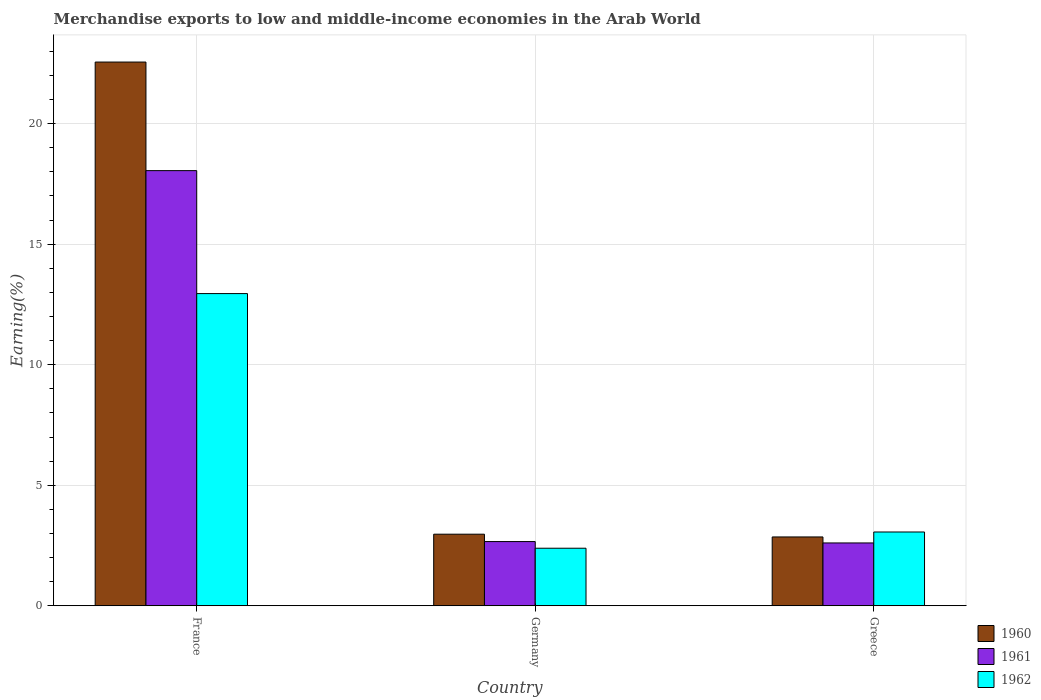How many different coloured bars are there?
Provide a succinct answer. 3. How many bars are there on the 3rd tick from the left?
Your answer should be compact. 3. How many bars are there on the 2nd tick from the right?
Offer a terse response. 3. In how many cases, is the number of bars for a given country not equal to the number of legend labels?
Your response must be concise. 0. What is the percentage of amount earned from merchandise exports in 1962 in Germany?
Offer a very short reply. 2.39. Across all countries, what is the maximum percentage of amount earned from merchandise exports in 1961?
Make the answer very short. 18.05. Across all countries, what is the minimum percentage of amount earned from merchandise exports in 1962?
Keep it short and to the point. 2.39. In which country was the percentage of amount earned from merchandise exports in 1962 maximum?
Provide a succinct answer. France. What is the total percentage of amount earned from merchandise exports in 1960 in the graph?
Your answer should be compact. 28.38. What is the difference between the percentage of amount earned from merchandise exports in 1960 in France and that in Greece?
Your answer should be compact. 19.7. What is the difference between the percentage of amount earned from merchandise exports in 1960 in Greece and the percentage of amount earned from merchandise exports in 1962 in Germany?
Make the answer very short. 0.47. What is the average percentage of amount earned from merchandise exports in 1961 per country?
Provide a short and direct response. 7.77. What is the difference between the percentage of amount earned from merchandise exports of/in 1961 and percentage of amount earned from merchandise exports of/in 1962 in Greece?
Make the answer very short. -0.45. In how many countries, is the percentage of amount earned from merchandise exports in 1961 greater than 5 %?
Your answer should be very brief. 1. What is the ratio of the percentage of amount earned from merchandise exports in 1962 in Germany to that in Greece?
Ensure brevity in your answer.  0.78. Is the percentage of amount earned from merchandise exports in 1961 in Germany less than that in Greece?
Offer a terse response. No. Is the difference between the percentage of amount earned from merchandise exports in 1961 in France and Greece greater than the difference between the percentage of amount earned from merchandise exports in 1962 in France and Greece?
Your answer should be very brief. Yes. What is the difference between the highest and the second highest percentage of amount earned from merchandise exports in 1962?
Your response must be concise. -0.67. What is the difference between the highest and the lowest percentage of amount earned from merchandise exports in 1960?
Your answer should be compact. 19.7. In how many countries, is the percentage of amount earned from merchandise exports in 1961 greater than the average percentage of amount earned from merchandise exports in 1961 taken over all countries?
Keep it short and to the point. 1. Is the sum of the percentage of amount earned from merchandise exports in 1960 in France and Germany greater than the maximum percentage of amount earned from merchandise exports in 1962 across all countries?
Provide a succinct answer. Yes. What does the 3rd bar from the right in France represents?
Offer a terse response. 1960. How many bars are there?
Provide a succinct answer. 9. Are all the bars in the graph horizontal?
Offer a very short reply. No. How many countries are there in the graph?
Provide a succinct answer. 3. Are the values on the major ticks of Y-axis written in scientific E-notation?
Your answer should be compact. No. Does the graph contain any zero values?
Provide a succinct answer. No. Does the graph contain grids?
Make the answer very short. Yes. Where does the legend appear in the graph?
Offer a terse response. Bottom right. How many legend labels are there?
Make the answer very short. 3. What is the title of the graph?
Provide a short and direct response. Merchandise exports to low and middle-income economies in the Arab World. Does "1998" appear as one of the legend labels in the graph?
Offer a very short reply. No. What is the label or title of the X-axis?
Provide a succinct answer. Country. What is the label or title of the Y-axis?
Offer a terse response. Earning(%). What is the Earning(%) in 1960 in France?
Provide a short and direct response. 22.55. What is the Earning(%) in 1961 in France?
Provide a short and direct response. 18.05. What is the Earning(%) of 1962 in France?
Your answer should be compact. 12.95. What is the Earning(%) in 1960 in Germany?
Provide a short and direct response. 2.97. What is the Earning(%) of 1961 in Germany?
Offer a very short reply. 2.66. What is the Earning(%) in 1962 in Germany?
Make the answer very short. 2.39. What is the Earning(%) of 1960 in Greece?
Your answer should be compact. 2.86. What is the Earning(%) of 1961 in Greece?
Offer a very short reply. 2.61. What is the Earning(%) in 1962 in Greece?
Ensure brevity in your answer.  3.06. Across all countries, what is the maximum Earning(%) of 1960?
Offer a very short reply. 22.55. Across all countries, what is the maximum Earning(%) of 1961?
Your answer should be compact. 18.05. Across all countries, what is the maximum Earning(%) of 1962?
Give a very brief answer. 12.95. Across all countries, what is the minimum Earning(%) of 1960?
Your answer should be compact. 2.86. Across all countries, what is the minimum Earning(%) in 1961?
Provide a succinct answer. 2.61. Across all countries, what is the minimum Earning(%) of 1962?
Your response must be concise. 2.39. What is the total Earning(%) of 1960 in the graph?
Offer a terse response. 28.38. What is the total Earning(%) in 1961 in the graph?
Offer a very short reply. 23.32. What is the total Earning(%) in 1962 in the graph?
Keep it short and to the point. 18.4. What is the difference between the Earning(%) in 1960 in France and that in Germany?
Ensure brevity in your answer.  19.58. What is the difference between the Earning(%) in 1961 in France and that in Germany?
Your answer should be compact. 15.38. What is the difference between the Earning(%) of 1962 in France and that in Germany?
Provide a short and direct response. 10.56. What is the difference between the Earning(%) of 1960 in France and that in Greece?
Ensure brevity in your answer.  19.7. What is the difference between the Earning(%) in 1961 in France and that in Greece?
Provide a succinct answer. 15.44. What is the difference between the Earning(%) of 1962 in France and that in Greece?
Ensure brevity in your answer.  9.89. What is the difference between the Earning(%) in 1960 in Germany and that in Greece?
Offer a terse response. 0.11. What is the difference between the Earning(%) of 1961 in Germany and that in Greece?
Ensure brevity in your answer.  0.06. What is the difference between the Earning(%) in 1962 in Germany and that in Greece?
Your answer should be compact. -0.67. What is the difference between the Earning(%) in 1960 in France and the Earning(%) in 1961 in Germany?
Provide a short and direct response. 19.89. What is the difference between the Earning(%) of 1960 in France and the Earning(%) of 1962 in Germany?
Provide a short and direct response. 20.16. What is the difference between the Earning(%) of 1961 in France and the Earning(%) of 1962 in Germany?
Your answer should be very brief. 15.66. What is the difference between the Earning(%) in 1960 in France and the Earning(%) in 1961 in Greece?
Ensure brevity in your answer.  19.95. What is the difference between the Earning(%) of 1960 in France and the Earning(%) of 1962 in Greece?
Give a very brief answer. 19.49. What is the difference between the Earning(%) of 1961 in France and the Earning(%) of 1962 in Greece?
Offer a very short reply. 14.99. What is the difference between the Earning(%) of 1960 in Germany and the Earning(%) of 1961 in Greece?
Offer a very short reply. 0.36. What is the difference between the Earning(%) of 1960 in Germany and the Earning(%) of 1962 in Greece?
Offer a very short reply. -0.09. What is the difference between the Earning(%) of 1961 in Germany and the Earning(%) of 1962 in Greece?
Your response must be concise. -0.4. What is the average Earning(%) in 1960 per country?
Provide a short and direct response. 9.46. What is the average Earning(%) in 1961 per country?
Provide a short and direct response. 7.77. What is the average Earning(%) of 1962 per country?
Provide a succinct answer. 6.13. What is the difference between the Earning(%) in 1960 and Earning(%) in 1961 in France?
Offer a very short reply. 4.5. What is the difference between the Earning(%) of 1960 and Earning(%) of 1962 in France?
Provide a succinct answer. 9.6. What is the difference between the Earning(%) in 1961 and Earning(%) in 1962 in France?
Offer a very short reply. 5.1. What is the difference between the Earning(%) of 1960 and Earning(%) of 1961 in Germany?
Provide a succinct answer. 0.31. What is the difference between the Earning(%) in 1960 and Earning(%) in 1962 in Germany?
Your answer should be compact. 0.58. What is the difference between the Earning(%) in 1961 and Earning(%) in 1962 in Germany?
Make the answer very short. 0.28. What is the difference between the Earning(%) of 1960 and Earning(%) of 1961 in Greece?
Keep it short and to the point. 0.25. What is the difference between the Earning(%) of 1960 and Earning(%) of 1962 in Greece?
Offer a very short reply. -0.21. What is the difference between the Earning(%) in 1961 and Earning(%) in 1962 in Greece?
Your response must be concise. -0.45. What is the ratio of the Earning(%) of 1960 in France to that in Germany?
Provide a short and direct response. 7.59. What is the ratio of the Earning(%) of 1961 in France to that in Germany?
Provide a succinct answer. 6.78. What is the ratio of the Earning(%) of 1962 in France to that in Germany?
Make the answer very short. 5.42. What is the ratio of the Earning(%) in 1960 in France to that in Greece?
Your answer should be very brief. 7.9. What is the ratio of the Earning(%) of 1961 in France to that in Greece?
Provide a short and direct response. 6.92. What is the ratio of the Earning(%) in 1962 in France to that in Greece?
Your answer should be very brief. 4.23. What is the ratio of the Earning(%) of 1961 in Germany to that in Greece?
Your answer should be very brief. 1.02. What is the ratio of the Earning(%) of 1962 in Germany to that in Greece?
Provide a short and direct response. 0.78. What is the difference between the highest and the second highest Earning(%) of 1960?
Give a very brief answer. 19.58. What is the difference between the highest and the second highest Earning(%) of 1961?
Keep it short and to the point. 15.38. What is the difference between the highest and the second highest Earning(%) of 1962?
Provide a short and direct response. 9.89. What is the difference between the highest and the lowest Earning(%) of 1960?
Ensure brevity in your answer.  19.7. What is the difference between the highest and the lowest Earning(%) of 1961?
Offer a very short reply. 15.44. What is the difference between the highest and the lowest Earning(%) in 1962?
Provide a short and direct response. 10.56. 